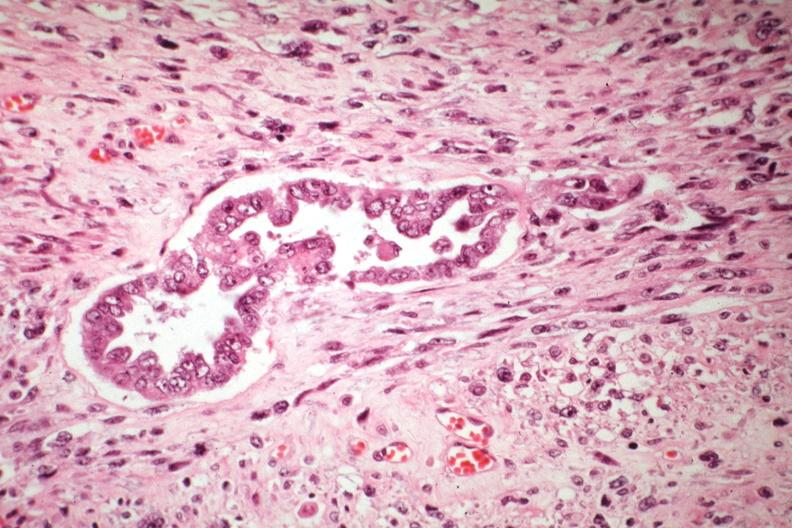what is present?
Answer the question using a single word or phrase. Mixed mesodermal tumor 